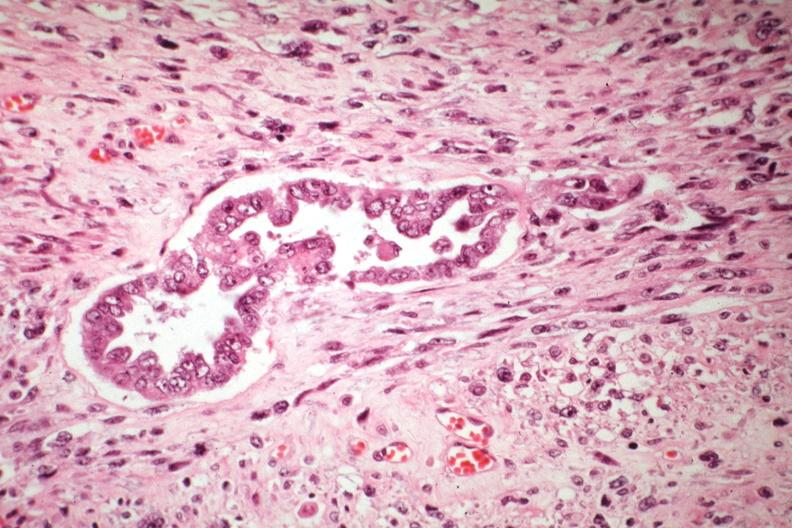what is present?
Answer the question using a single word or phrase. Mixed mesodermal tumor 